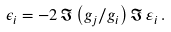Convert formula to latex. <formula><loc_0><loc_0><loc_500><loc_500>\epsilon _ { i } = - 2 \, \Im \left ( g _ { j } / g _ { i } \right ) \Im \, \varepsilon _ { i } \, .</formula> 